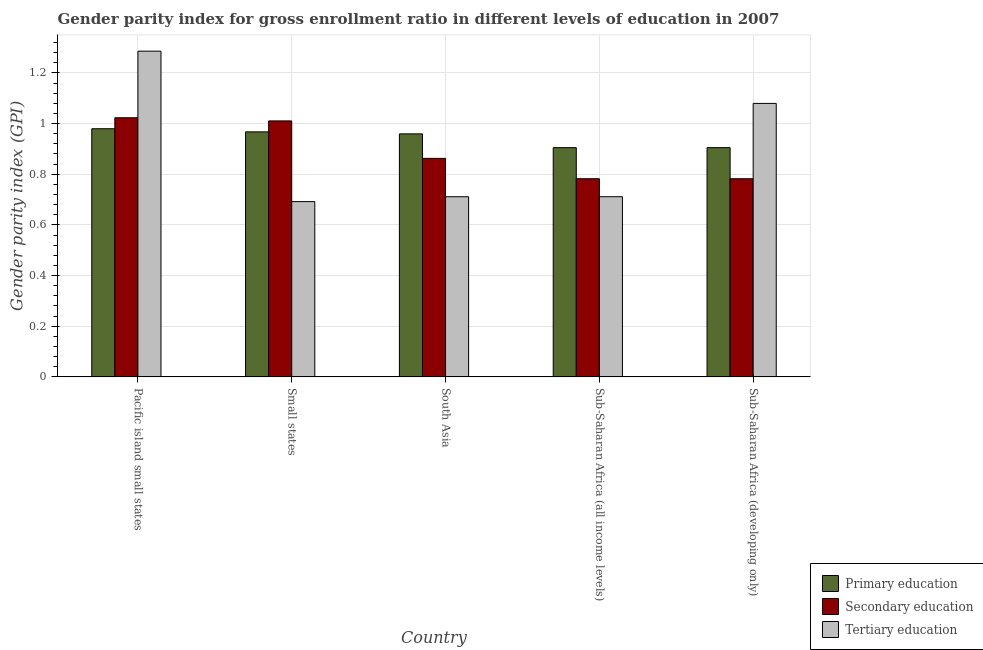How many groups of bars are there?
Provide a short and direct response. 5. Are the number of bars per tick equal to the number of legend labels?
Provide a succinct answer. Yes. Are the number of bars on each tick of the X-axis equal?
Your answer should be very brief. Yes. What is the label of the 3rd group of bars from the left?
Provide a succinct answer. South Asia. In how many cases, is the number of bars for a given country not equal to the number of legend labels?
Your response must be concise. 0. What is the gender parity index in secondary education in Pacific island small states?
Make the answer very short. 1.02. Across all countries, what is the maximum gender parity index in secondary education?
Make the answer very short. 1.02. Across all countries, what is the minimum gender parity index in secondary education?
Your answer should be very brief. 0.78. In which country was the gender parity index in tertiary education maximum?
Ensure brevity in your answer.  Pacific island small states. In which country was the gender parity index in secondary education minimum?
Keep it short and to the point. Sub-Saharan Africa (developing only). What is the total gender parity index in primary education in the graph?
Provide a succinct answer. 4.72. What is the difference between the gender parity index in primary education in Small states and that in Sub-Saharan Africa (all income levels)?
Give a very brief answer. 0.06. What is the difference between the gender parity index in primary education in Small states and the gender parity index in tertiary education in Pacific island small states?
Offer a very short reply. -0.32. What is the average gender parity index in secondary education per country?
Make the answer very short. 0.89. What is the difference between the gender parity index in secondary education and gender parity index in tertiary education in Pacific island small states?
Offer a very short reply. -0.26. In how many countries, is the gender parity index in tertiary education greater than 0.4 ?
Your answer should be compact. 5. What is the ratio of the gender parity index in primary education in Pacific island small states to that in Sub-Saharan Africa (developing only)?
Make the answer very short. 1.08. Is the difference between the gender parity index in tertiary education in South Asia and Sub-Saharan Africa (all income levels) greater than the difference between the gender parity index in primary education in South Asia and Sub-Saharan Africa (all income levels)?
Give a very brief answer. No. What is the difference between the highest and the second highest gender parity index in secondary education?
Your answer should be very brief. 0.01. What is the difference between the highest and the lowest gender parity index in primary education?
Your response must be concise. 0.07. What does the 2nd bar from the left in Pacific island small states represents?
Give a very brief answer. Secondary education. What does the 1st bar from the right in Sub-Saharan Africa (developing only) represents?
Provide a short and direct response. Tertiary education. Is it the case that in every country, the sum of the gender parity index in primary education and gender parity index in secondary education is greater than the gender parity index in tertiary education?
Ensure brevity in your answer.  Yes. Are the values on the major ticks of Y-axis written in scientific E-notation?
Your answer should be very brief. No. Does the graph contain any zero values?
Make the answer very short. No. How are the legend labels stacked?
Give a very brief answer. Vertical. What is the title of the graph?
Keep it short and to the point. Gender parity index for gross enrollment ratio in different levels of education in 2007. What is the label or title of the X-axis?
Your answer should be compact. Country. What is the label or title of the Y-axis?
Give a very brief answer. Gender parity index (GPI). What is the Gender parity index (GPI) of Primary education in Pacific island small states?
Offer a very short reply. 0.98. What is the Gender parity index (GPI) of Secondary education in Pacific island small states?
Keep it short and to the point. 1.02. What is the Gender parity index (GPI) of Tertiary education in Pacific island small states?
Your response must be concise. 1.29. What is the Gender parity index (GPI) of Primary education in Small states?
Keep it short and to the point. 0.97. What is the Gender parity index (GPI) in Secondary education in Small states?
Ensure brevity in your answer.  1.01. What is the Gender parity index (GPI) in Tertiary education in Small states?
Provide a succinct answer. 0.69. What is the Gender parity index (GPI) of Primary education in South Asia?
Make the answer very short. 0.96. What is the Gender parity index (GPI) of Secondary education in South Asia?
Provide a short and direct response. 0.86. What is the Gender parity index (GPI) of Tertiary education in South Asia?
Provide a short and direct response. 0.71. What is the Gender parity index (GPI) in Primary education in Sub-Saharan Africa (all income levels)?
Your response must be concise. 0.91. What is the Gender parity index (GPI) of Secondary education in Sub-Saharan Africa (all income levels)?
Make the answer very short. 0.78. What is the Gender parity index (GPI) in Tertiary education in Sub-Saharan Africa (all income levels)?
Offer a very short reply. 0.71. What is the Gender parity index (GPI) in Primary education in Sub-Saharan Africa (developing only)?
Your answer should be very brief. 0.91. What is the Gender parity index (GPI) of Secondary education in Sub-Saharan Africa (developing only)?
Keep it short and to the point. 0.78. What is the Gender parity index (GPI) of Tertiary education in Sub-Saharan Africa (developing only)?
Offer a terse response. 1.08. Across all countries, what is the maximum Gender parity index (GPI) in Primary education?
Give a very brief answer. 0.98. Across all countries, what is the maximum Gender parity index (GPI) of Secondary education?
Your response must be concise. 1.02. Across all countries, what is the maximum Gender parity index (GPI) in Tertiary education?
Make the answer very short. 1.29. Across all countries, what is the minimum Gender parity index (GPI) of Primary education?
Ensure brevity in your answer.  0.91. Across all countries, what is the minimum Gender parity index (GPI) in Secondary education?
Provide a succinct answer. 0.78. Across all countries, what is the minimum Gender parity index (GPI) of Tertiary education?
Your answer should be very brief. 0.69. What is the total Gender parity index (GPI) in Primary education in the graph?
Your response must be concise. 4.72. What is the total Gender parity index (GPI) in Secondary education in the graph?
Offer a terse response. 4.46. What is the total Gender parity index (GPI) of Tertiary education in the graph?
Offer a terse response. 4.48. What is the difference between the Gender parity index (GPI) of Primary education in Pacific island small states and that in Small states?
Provide a succinct answer. 0.01. What is the difference between the Gender parity index (GPI) of Secondary education in Pacific island small states and that in Small states?
Make the answer very short. 0.01. What is the difference between the Gender parity index (GPI) in Tertiary education in Pacific island small states and that in Small states?
Provide a succinct answer. 0.59. What is the difference between the Gender parity index (GPI) of Primary education in Pacific island small states and that in South Asia?
Provide a short and direct response. 0.02. What is the difference between the Gender parity index (GPI) of Secondary education in Pacific island small states and that in South Asia?
Keep it short and to the point. 0.16. What is the difference between the Gender parity index (GPI) in Tertiary education in Pacific island small states and that in South Asia?
Provide a short and direct response. 0.57. What is the difference between the Gender parity index (GPI) in Primary education in Pacific island small states and that in Sub-Saharan Africa (all income levels)?
Ensure brevity in your answer.  0.07. What is the difference between the Gender parity index (GPI) in Secondary education in Pacific island small states and that in Sub-Saharan Africa (all income levels)?
Provide a short and direct response. 0.24. What is the difference between the Gender parity index (GPI) of Tertiary education in Pacific island small states and that in Sub-Saharan Africa (all income levels)?
Make the answer very short. 0.57. What is the difference between the Gender parity index (GPI) in Primary education in Pacific island small states and that in Sub-Saharan Africa (developing only)?
Your answer should be very brief. 0.07. What is the difference between the Gender parity index (GPI) of Secondary education in Pacific island small states and that in Sub-Saharan Africa (developing only)?
Provide a short and direct response. 0.24. What is the difference between the Gender parity index (GPI) in Tertiary education in Pacific island small states and that in Sub-Saharan Africa (developing only)?
Ensure brevity in your answer.  0.21. What is the difference between the Gender parity index (GPI) in Primary education in Small states and that in South Asia?
Ensure brevity in your answer.  0.01. What is the difference between the Gender parity index (GPI) of Secondary education in Small states and that in South Asia?
Offer a terse response. 0.15. What is the difference between the Gender parity index (GPI) of Tertiary education in Small states and that in South Asia?
Make the answer very short. -0.02. What is the difference between the Gender parity index (GPI) in Primary education in Small states and that in Sub-Saharan Africa (all income levels)?
Provide a short and direct response. 0.06. What is the difference between the Gender parity index (GPI) in Secondary education in Small states and that in Sub-Saharan Africa (all income levels)?
Make the answer very short. 0.23. What is the difference between the Gender parity index (GPI) in Tertiary education in Small states and that in Sub-Saharan Africa (all income levels)?
Offer a very short reply. -0.02. What is the difference between the Gender parity index (GPI) of Primary education in Small states and that in Sub-Saharan Africa (developing only)?
Offer a very short reply. 0.06. What is the difference between the Gender parity index (GPI) in Secondary education in Small states and that in Sub-Saharan Africa (developing only)?
Your answer should be compact. 0.23. What is the difference between the Gender parity index (GPI) of Tertiary education in Small states and that in Sub-Saharan Africa (developing only)?
Offer a terse response. -0.39. What is the difference between the Gender parity index (GPI) of Primary education in South Asia and that in Sub-Saharan Africa (all income levels)?
Provide a short and direct response. 0.05. What is the difference between the Gender parity index (GPI) in Secondary education in South Asia and that in Sub-Saharan Africa (all income levels)?
Keep it short and to the point. 0.08. What is the difference between the Gender parity index (GPI) in Tertiary education in South Asia and that in Sub-Saharan Africa (all income levels)?
Keep it short and to the point. -0. What is the difference between the Gender parity index (GPI) in Primary education in South Asia and that in Sub-Saharan Africa (developing only)?
Your response must be concise. 0.05. What is the difference between the Gender parity index (GPI) in Secondary education in South Asia and that in Sub-Saharan Africa (developing only)?
Provide a succinct answer. 0.08. What is the difference between the Gender parity index (GPI) of Tertiary education in South Asia and that in Sub-Saharan Africa (developing only)?
Your response must be concise. -0.37. What is the difference between the Gender parity index (GPI) of Tertiary education in Sub-Saharan Africa (all income levels) and that in Sub-Saharan Africa (developing only)?
Offer a very short reply. -0.37. What is the difference between the Gender parity index (GPI) of Primary education in Pacific island small states and the Gender parity index (GPI) of Secondary education in Small states?
Offer a very short reply. -0.03. What is the difference between the Gender parity index (GPI) in Primary education in Pacific island small states and the Gender parity index (GPI) in Tertiary education in Small states?
Offer a very short reply. 0.29. What is the difference between the Gender parity index (GPI) of Secondary education in Pacific island small states and the Gender parity index (GPI) of Tertiary education in Small states?
Offer a terse response. 0.33. What is the difference between the Gender parity index (GPI) of Primary education in Pacific island small states and the Gender parity index (GPI) of Secondary education in South Asia?
Provide a succinct answer. 0.12. What is the difference between the Gender parity index (GPI) of Primary education in Pacific island small states and the Gender parity index (GPI) of Tertiary education in South Asia?
Ensure brevity in your answer.  0.27. What is the difference between the Gender parity index (GPI) of Secondary education in Pacific island small states and the Gender parity index (GPI) of Tertiary education in South Asia?
Provide a succinct answer. 0.31. What is the difference between the Gender parity index (GPI) of Primary education in Pacific island small states and the Gender parity index (GPI) of Secondary education in Sub-Saharan Africa (all income levels)?
Provide a succinct answer. 0.2. What is the difference between the Gender parity index (GPI) in Primary education in Pacific island small states and the Gender parity index (GPI) in Tertiary education in Sub-Saharan Africa (all income levels)?
Provide a short and direct response. 0.27. What is the difference between the Gender parity index (GPI) in Secondary education in Pacific island small states and the Gender parity index (GPI) in Tertiary education in Sub-Saharan Africa (all income levels)?
Provide a succinct answer. 0.31. What is the difference between the Gender parity index (GPI) in Primary education in Pacific island small states and the Gender parity index (GPI) in Secondary education in Sub-Saharan Africa (developing only)?
Provide a succinct answer. 0.2. What is the difference between the Gender parity index (GPI) in Primary education in Pacific island small states and the Gender parity index (GPI) in Tertiary education in Sub-Saharan Africa (developing only)?
Provide a succinct answer. -0.1. What is the difference between the Gender parity index (GPI) of Secondary education in Pacific island small states and the Gender parity index (GPI) of Tertiary education in Sub-Saharan Africa (developing only)?
Give a very brief answer. -0.06. What is the difference between the Gender parity index (GPI) in Primary education in Small states and the Gender parity index (GPI) in Secondary education in South Asia?
Ensure brevity in your answer.  0.1. What is the difference between the Gender parity index (GPI) in Primary education in Small states and the Gender parity index (GPI) in Tertiary education in South Asia?
Your answer should be compact. 0.26. What is the difference between the Gender parity index (GPI) of Secondary education in Small states and the Gender parity index (GPI) of Tertiary education in South Asia?
Provide a succinct answer. 0.3. What is the difference between the Gender parity index (GPI) in Primary education in Small states and the Gender parity index (GPI) in Secondary education in Sub-Saharan Africa (all income levels)?
Your answer should be very brief. 0.19. What is the difference between the Gender parity index (GPI) in Primary education in Small states and the Gender parity index (GPI) in Tertiary education in Sub-Saharan Africa (all income levels)?
Offer a terse response. 0.26. What is the difference between the Gender parity index (GPI) in Secondary education in Small states and the Gender parity index (GPI) in Tertiary education in Sub-Saharan Africa (all income levels)?
Offer a terse response. 0.3. What is the difference between the Gender parity index (GPI) of Primary education in Small states and the Gender parity index (GPI) of Secondary education in Sub-Saharan Africa (developing only)?
Your answer should be compact. 0.19. What is the difference between the Gender parity index (GPI) of Primary education in Small states and the Gender parity index (GPI) of Tertiary education in Sub-Saharan Africa (developing only)?
Make the answer very short. -0.11. What is the difference between the Gender parity index (GPI) in Secondary education in Small states and the Gender parity index (GPI) in Tertiary education in Sub-Saharan Africa (developing only)?
Your answer should be compact. -0.07. What is the difference between the Gender parity index (GPI) in Primary education in South Asia and the Gender parity index (GPI) in Secondary education in Sub-Saharan Africa (all income levels)?
Give a very brief answer. 0.18. What is the difference between the Gender parity index (GPI) in Primary education in South Asia and the Gender parity index (GPI) in Tertiary education in Sub-Saharan Africa (all income levels)?
Make the answer very short. 0.25. What is the difference between the Gender parity index (GPI) of Secondary education in South Asia and the Gender parity index (GPI) of Tertiary education in Sub-Saharan Africa (all income levels)?
Your answer should be compact. 0.15. What is the difference between the Gender parity index (GPI) in Primary education in South Asia and the Gender parity index (GPI) in Secondary education in Sub-Saharan Africa (developing only)?
Offer a terse response. 0.18. What is the difference between the Gender parity index (GPI) in Primary education in South Asia and the Gender parity index (GPI) in Tertiary education in Sub-Saharan Africa (developing only)?
Offer a terse response. -0.12. What is the difference between the Gender parity index (GPI) in Secondary education in South Asia and the Gender parity index (GPI) in Tertiary education in Sub-Saharan Africa (developing only)?
Keep it short and to the point. -0.22. What is the difference between the Gender parity index (GPI) in Primary education in Sub-Saharan Africa (all income levels) and the Gender parity index (GPI) in Secondary education in Sub-Saharan Africa (developing only)?
Your response must be concise. 0.12. What is the difference between the Gender parity index (GPI) of Primary education in Sub-Saharan Africa (all income levels) and the Gender parity index (GPI) of Tertiary education in Sub-Saharan Africa (developing only)?
Your response must be concise. -0.17. What is the difference between the Gender parity index (GPI) in Secondary education in Sub-Saharan Africa (all income levels) and the Gender parity index (GPI) in Tertiary education in Sub-Saharan Africa (developing only)?
Offer a very short reply. -0.3. What is the average Gender parity index (GPI) of Primary education per country?
Provide a succinct answer. 0.94. What is the average Gender parity index (GPI) in Secondary education per country?
Ensure brevity in your answer.  0.89. What is the average Gender parity index (GPI) of Tertiary education per country?
Give a very brief answer. 0.9. What is the difference between the Gender parity index (GPI) of Primary education and Gender parity index (GPI) of Secondary education in Pacific island small states?
Offer a terse response. -0.04. What is the difference between the Gender parity index (GPI) in Primary education and Gender parity index (GPI) in Tertiary education in Pacific island small states?
Ensure brevity in your answer.  -0.31. What is the difference between the Gender parity index (GPI) in Secondary education and Gender parity index (GPI) in Tertiary education in Pacific island small states?
Ensure brevity in your answer.  -0.26. What is the difference between the Gender parity index (GPI) of Primary education and Gender parity index (GPI) of Secondary education in Small states?
Give a very brief answer. -0.04. What is the difference between the Gender parity index (GPI) of Primary education and Gender parity index (GPI) of Tertiary education in Small states?
Keep it short and to the point. 0.28. What is the difference between the Gender parity index (GPI) of Secondary education and Gender parity index (GPI) of Tertiary education in Small states?
Your answer should be very brief. 0.32. What is the difference between the Gender parity index (GPI) in Primary education and Gender parity index (GPI) in Secondary education in South Asia?
Make the answer very short. 0.1. What is the difference between the Gender parity index (GPI) of Primary education and Gender parity index (GPI) of Tertiary education in South Asia?
Your answer should be compact. 0.25. What is the difference between the Gender parity index (GPI) in Secondary education and Gender parity index (GPI) in Tertiary education in South Asia?
Provide a succinct answer. 0.15. What is the difference between the Gender parity index (GPI) of Primary education and Gender parity index (GPI) of Secondary education in Sub-Saharan Africa (all income levels)?
Offer a terse response. 0.12. What is the difference between the Gender parity index (GPI) in Primary education and Gender parity index (GPI) in Tertiary education in Sub-Saharan Africa (all income levels)?
Ensure brevity in your answer.  0.19. What is the difference between the Gender parity index (GPI) of Secondary education and Gender parity index (GPI) of Tertiary education in Sub-Saharan Africa (all income levels)?
Make the answer very short. 0.07. What is the difference between the Gender parity index (GPI) in Primary education and Gender parity index (GPI) in Secondary education in Sub-Saharan Africa (developing only)?
Provide a succinct answer. 0.12. What is the difference between the Gender parity index (GPI) of Primary education and Gender parity index (GPI) of Tertiary education in Sub-Saharan Africa (developing only)?
Your response must be concise. -0.17. What is the difference between the Gender parity index (GPI) of Secondary education and Gender parity index (GPI) of Tertiary education in Sub-Saharan Africa (developing only)?
Offer a terse response. -0.3. What is the ratio of the Gender parity index (GPI) in Primary education in Pacific island small states to that in Small states?
Make the answer very short. 1.01. What is the ratio of the Gender parity index (GPI) in Secondary education in Pacific island small states to that in Small states?
Keep it short and to the point. 1.01. What is the ratio of the Gender parity index (GPI) of Tertiary education in Pacific island small states to that in Small states?
Provide a succinct answer. 1.86. What is the ratio of the Gender parity index (GPI) of Primary education in Pacific island small states to that in South Asia?
Offer a terse response. 1.02. What is the ratio of the Gender parity index (GPI) in Secondary education in Pacific island small states to that in South Asia?
Make the answer very short. 1.19. What is the ratio of the Gender parity index (GPI) in Tertiary education in Pacific island small states to that in South Asia?
Your answer should be compact. 1.81. What is the ratio of the Gender parity index (GPI) in Primary education in Pacific island small states to that in Sub-Saharan Africa (all income levels)?
Your answer should be compact. 1.08. What is the ratio of the Gender parity index (GPI) of Secondary education in Pacific island small states to that in Sub-Saharan Africa (all income levels)?
Offer a very short reply. 1.31. What is the ratio of the Gender parity index (GPI) of Tertiary education in Pacific island small states to that in Sub-Saharan Africa (all income levels)?
Provide a short and direct response. 1.81. What is the ratio of the Gender parity index (GPI) of Primary education in Pacific island small states to that in Sub-Saharan Africa (developing only)?
Provide a short and direct response. 1.08. What is the ratio of the Gender parity index (GPI) in Secondary education in Pacific island small states to that in Sub-Saharan Africa (developing only)?
Your answer should be compact. 1.31. What is the ratio of the Gender parity index (GPI) in Tertiary education in Pacific island small states to that in Sub-Saharan Africa (developing only)?
Your answer should be very brief. 1.19. What is the ratio of the Gender parity index (GPI) of Primary education in Small states to that in South Asia?
Keep it short and to the point. 1.01. What is the ratio of the Gender parity index (GPI) of Secondary education in Small states to that in South Asia?
Make the answer very short. 1.17. What is the ratio of the Gender parity index (GPI) of Primary education in Small states to that in Sub-Saharan Africa (all income levels)?
Offer a terse response. 1.07. What is the ratio of the Gender parity index (GPI) in Secondary education in Small states to that in Sub-Saharan Africa (all income levels)?
Your answer should be compact. 1.29. What is the ratio of the Gender parity index (GPI) in Tertiary education in Small states to that in Sub-Saharan Africa (all income levels)?
Your answer should be compact. 0.97. What is the ratio of the Gender parity index (GPI) of Primary education in Small states to that in Sub-Saharan Africa (developing only)?
Keep it short and to the point. 1.07. What is the ratio of the Gender parity index (GPI) in Secondary education in Small states to that in Sub-Saharan Africa (developing only)?
Your answer should be compact. 1.29. What is the ratio of the Gender parity index (GPI) of Tertiary education in Small states to that in Sub-Saharan Africa (developing only)?
Give a very brief answer. 0.64. What is the ratio of the Gender parity index (GPI) in Primary education in South Asia to that in Sub-Saharan Africa (all income levels)?
Keep it short and to the point. 1.06. What is the ratio of the Gender parity index (GPI) in Secondary education in South Asia to that in Sub-Saharan Africa (all income levels)?
Offer a terse response. 1.1. What is the ratio of the Gender parity index (GPI) in Tertiary education in South Asia to that in Sub-Saharan Africa (all income levels)?
Provide a succinct answer. 1. What is the ratio of the Gender parity index (GPI) in Primary education in South Asia to that in Sub-Saharan Africa (developing only)?
Offer a terse response. 1.06. What is the ratio of the Gender parity index (GPI) in Secondary education in South Asia to that in Sub-Saharan Africa (developing only)?
Your answer should be very brief. 1.1. What is the ratio of the Gender parity index (GPI) in Tertiary education in South Asia to that in Sub-Saharan Africa (developing only)?
Ensure brevity in your answer.  0.66. What is the ratio of the Gender parity index (GPI) of Primary education in Sub-Saharan Africa (all income levels) to that in Sub-Saharan Africa (developing only)?
Offer a very short reply. 1. What is the ratio of the Gender parity index (GPI) in Tertiary education in Sub-Saharan Africa (all income levels) to that in Sub-Saharan Africa (developing only)?
Provide a short and direct response. 0.66. What is the difference between the highest and the second highest Gender parity index (GPI) of Primary education?
Keep it short and to the point. 0.01. What is the difference between the highest and the second highest Gender parity index (GPI) of Secondary education?
Your answer should be compact. 0.01. What is the difference between the highest and the second highest Gender parity index (GPI) of Tertiary education?
Give a very brief answer. 0.21. What is the difference between the highest and the lowest Gender parity index (GPI) of Primary education?
Provide a short and direct response. 0.07. What is the difference between the highest and the lowest Gender parity index (GPI) of Secondary education?
Provide a short and direct response. 0.24. What is the difference between the highest and the lowest Gender parity index (GPI) of Tertiary education?
Your response must be concise. 0.59. 